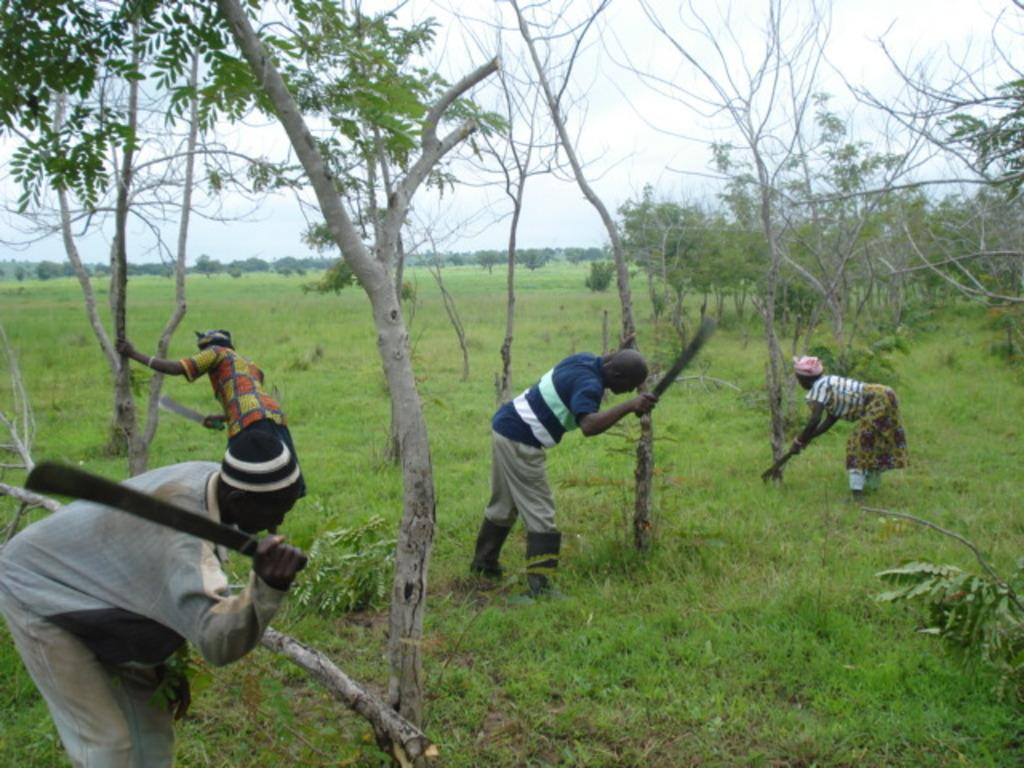Who or what is present in the image? There are people in the image. What are the people wearing? The people are wearing clothes. What are the people holding in their hands? The people are holding swords in their hands. What can be seen in the middle of the image? There are trees in the middle of the image. What is visible at the top of the image? The sky is visible at the top of the image. What type of plate is being used by the dolls in the image? There are no dolls present in the image, and therefore no plates can be associated with them. 